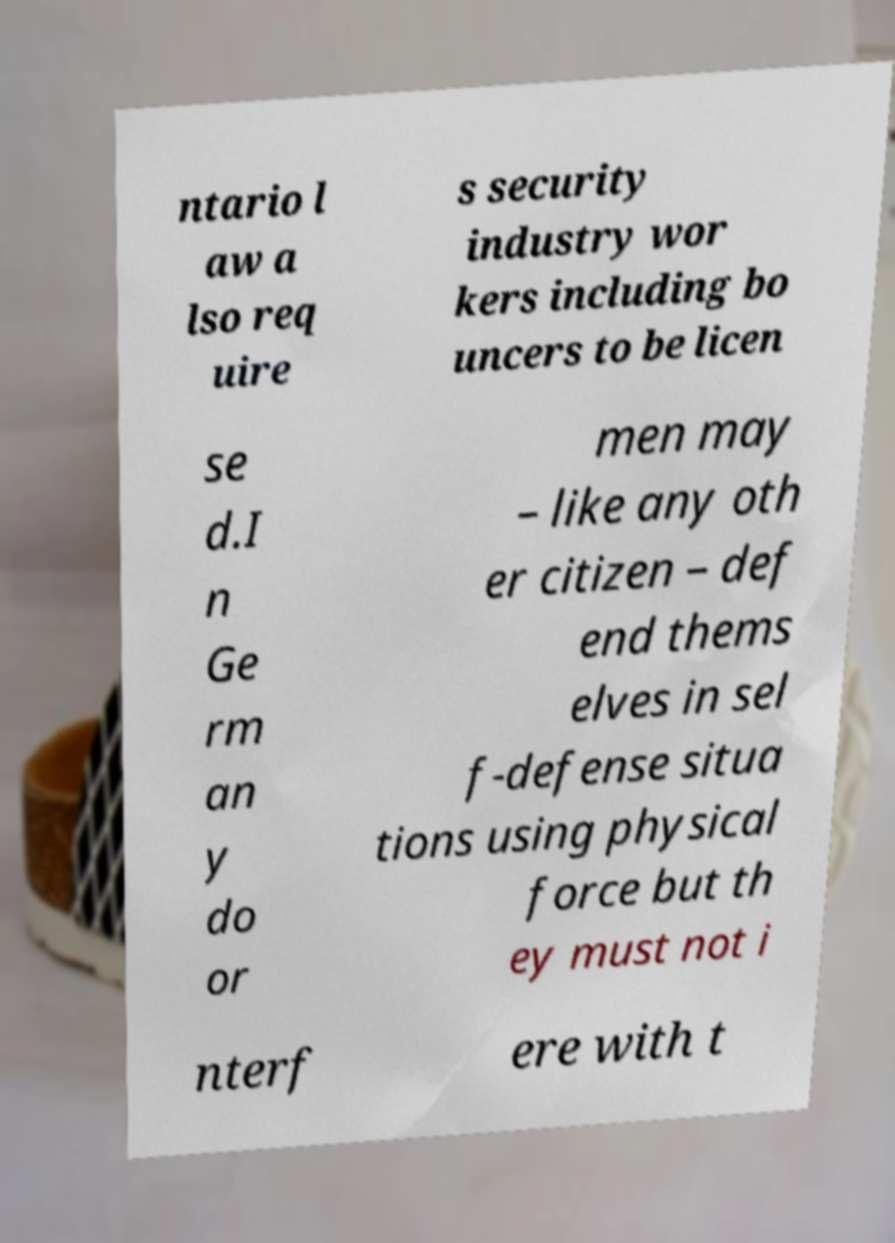I need the written content from this picture converted into text. Can you do that? ntario l aw a lso req uire s security industry wor kers including bo uncers to be licen se d.I n Ge rm an y do or men may – like any oth er citizen – def end thems elves in sel f-defense situa tions using physical force but th ey must not i nterf ere with t 